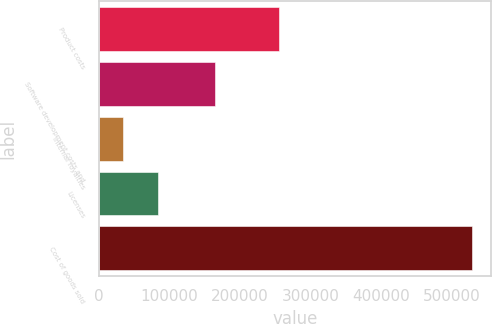Convert chart. <chart><loc_0><loc_0><loc_500><loc_500><bar_chart><fcel>Product costs<fcel>Software development costs and<fcel>Internal royalties<fcel>Licenses<fcel>Cost of goods sold<nl><fcel>255236<fcel>164487<fcel>34156<fcel>83625.9<fcel>528855<nl></chart> 